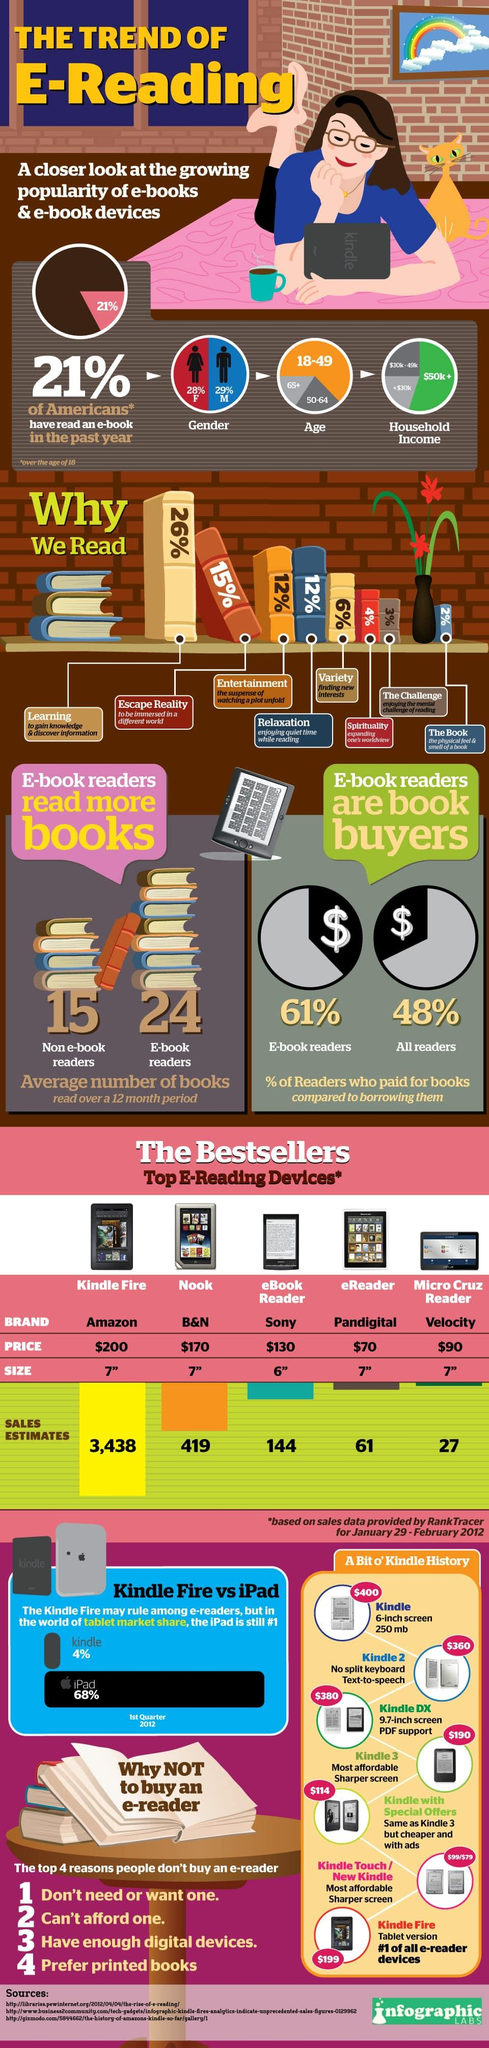Outline some significant characteristics in this image. The majority of people believe that the purpose of reading is to learn. The least expensive e-reading device among the top 5 is the eReader. The Kindle Fire is the best-selling e-reading device among all other available options. Among the top 5 e-reading devices available, the one with a 6-inch size is the eBook reader. The Nook is the second best-selling e-reading device, among other e-reading devices. 